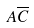<formula> <loc_0><loc_0><loc_500><loc_500>A \overline { C }</formula> 